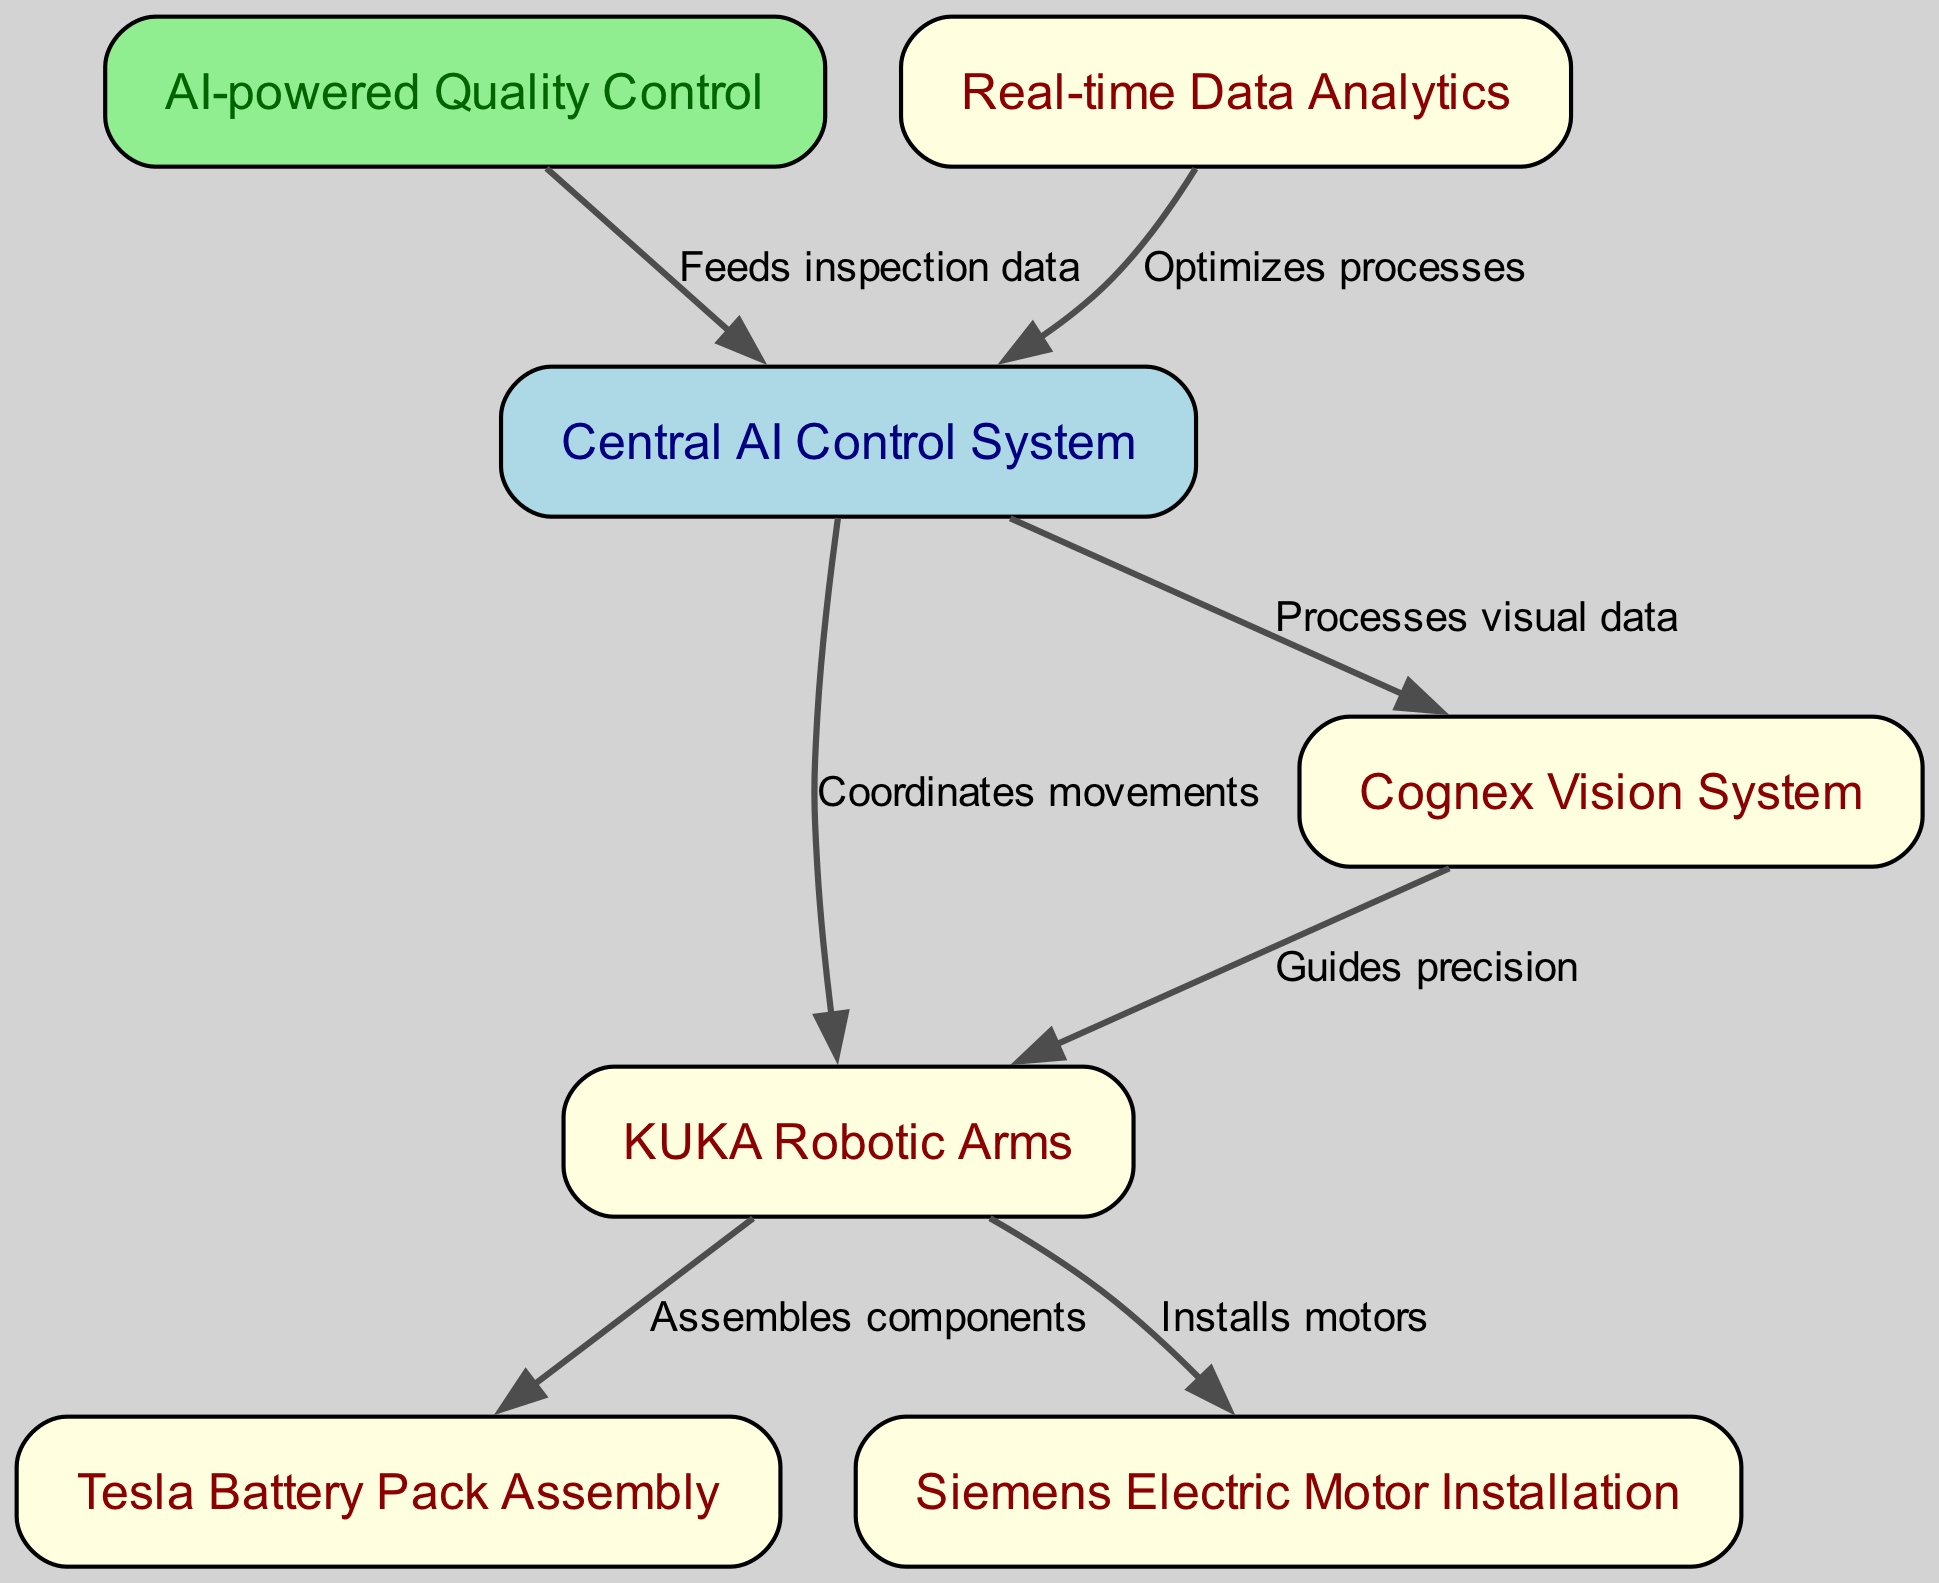What is the total number of nodes in the diagram? The diagram contains a total of 7 nodes, which are: Central AI Control System, KUKA Robotic Arms, Cognex Vision System, Tesla Battery Pack Assembly, Siemens Electric Motor Installation, AI-powered Quality Control, and Real-time Data Analytics. Counting these nodes gives us 7.
Answer: 7 Who coordinates the movements of the robotic arms? The edge from the Central AI Control System to the KUKA Robotic Arms indicates that the Central AI Control System is responsible for coordinating their movements.
Answer: Central AI Control System What role does the Cognex Vision System play in relation to the robotic arms? The diagram shows a directed edge from the Cognex Vision System to the KUKA Robotic Arms, labeled "Guides precision," indicating that it provides guidance to the robotic arms for precise operations.
Answer: Guides precision Which node is responsible for optimizing processes? The Real-time Data Analytics node sends information to the Central AI Control System, thereby optimizing the overall assembly line processes.
Answer: Real-time Data Analytics What type of data does the AI-powered Quality Control feed back into? The directed edge from the AI-powered Quality Control to the Central AI Control System indicates that it feeds inspection data back into the AI Control System, contributing to quality assurance.
Answer: Inspection data How many edges are present in the diagram? The diagram consists of 7 directed edges, which represent the relationships between the nodes: coordination, guiding, assembling, installation, feeding data, and optimization. Counting these edges yields a total of 7.
Answer: 7 Which assembly process does the KUKA Robotic Arms not participate in? The KUKA Robotic Arms are involved in both Tesla Battery Pack Assembly and Siemens Electric Motor Installation, but they do not participate in any assembly processes related to Vision System or Quality Control. Thus, the KUKA Robotic Arms do not participate in either quality control or data analytics.
Answer: Quality Control What function does the AI Control System serve in the overall assembly line? The Central AI Control System acts as the brain of the assembly line, coordinating movements and processing data from various systems, thereby ensuring the assembly line operates efficiently.
Answer: Brain What does the edge labeled "Processes visual data" indicate? This edge shows the direct relationship from the Central AI Control System to the Cognex Vision System, illustrating that the AI Control System is responsible for processing the visual data that is essential for assembly operations.
Answer: Processes visual data 